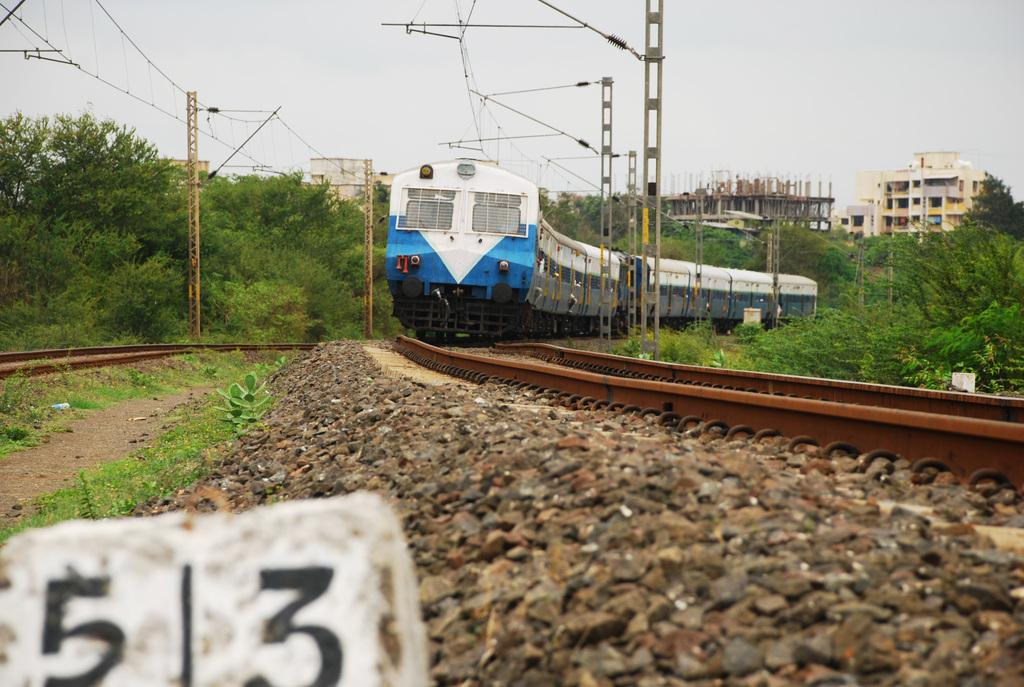Provide a one-sentence caption for the provided image. A train is pulling up to marker 513. 